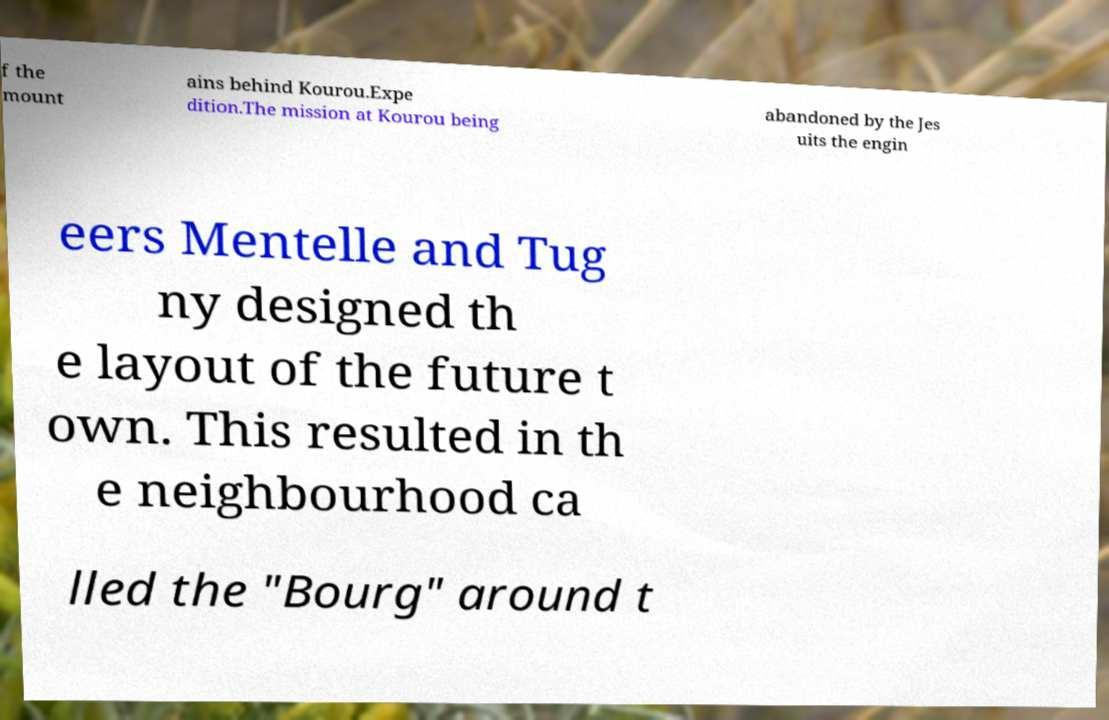Could you assist in decoding the text presented in this image and type it out clearly? f the mount ains behind Kourou.Expe dition.The mission at Kourou being abandoned by the Jes uits the engin eers Mentelle and Tug ny designed th e layout of the future t own. This resulted in th e neighbourhood ca lled the "Bourg" around t 